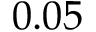<formula> <loc_0><loc_0><loc_500><loc_500>0 . 0 5</formula> 